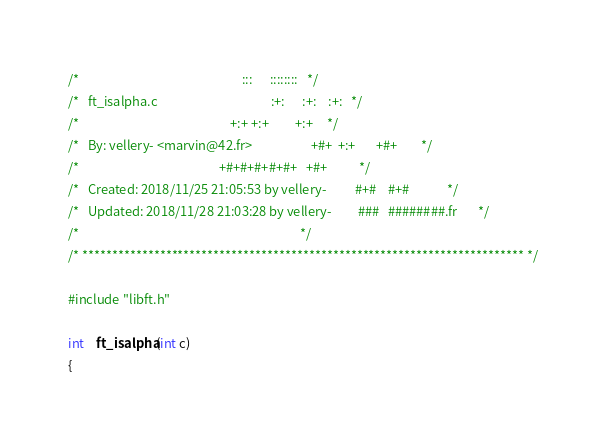Convert code to text. <code><loc_0><loc_0><loc_500><loc_500><_C_>/*                                                        :::      ::::::::   */
/*   ft_isalpha.c                                       :+:      :+:    :+:   */
/*                                                    +:+ +:+         +:+     */
/*   By: vellery- <marvin@42.fr>                    +#+  +:+       +#+        */
/*                                                +#+#+#+#+#+   +#+           */
/*   Created: 2018/11/25 21:05:53 by vellery-          #+#    #+#             */
/*   Updated: 2018/11/28 21:03:28 by vellery-         ###   ########.fr       */
/*                                                                            */
/* ************************************************************************** */

#include "libft.h"

int	ft_isalpha(int c)
{</code> 